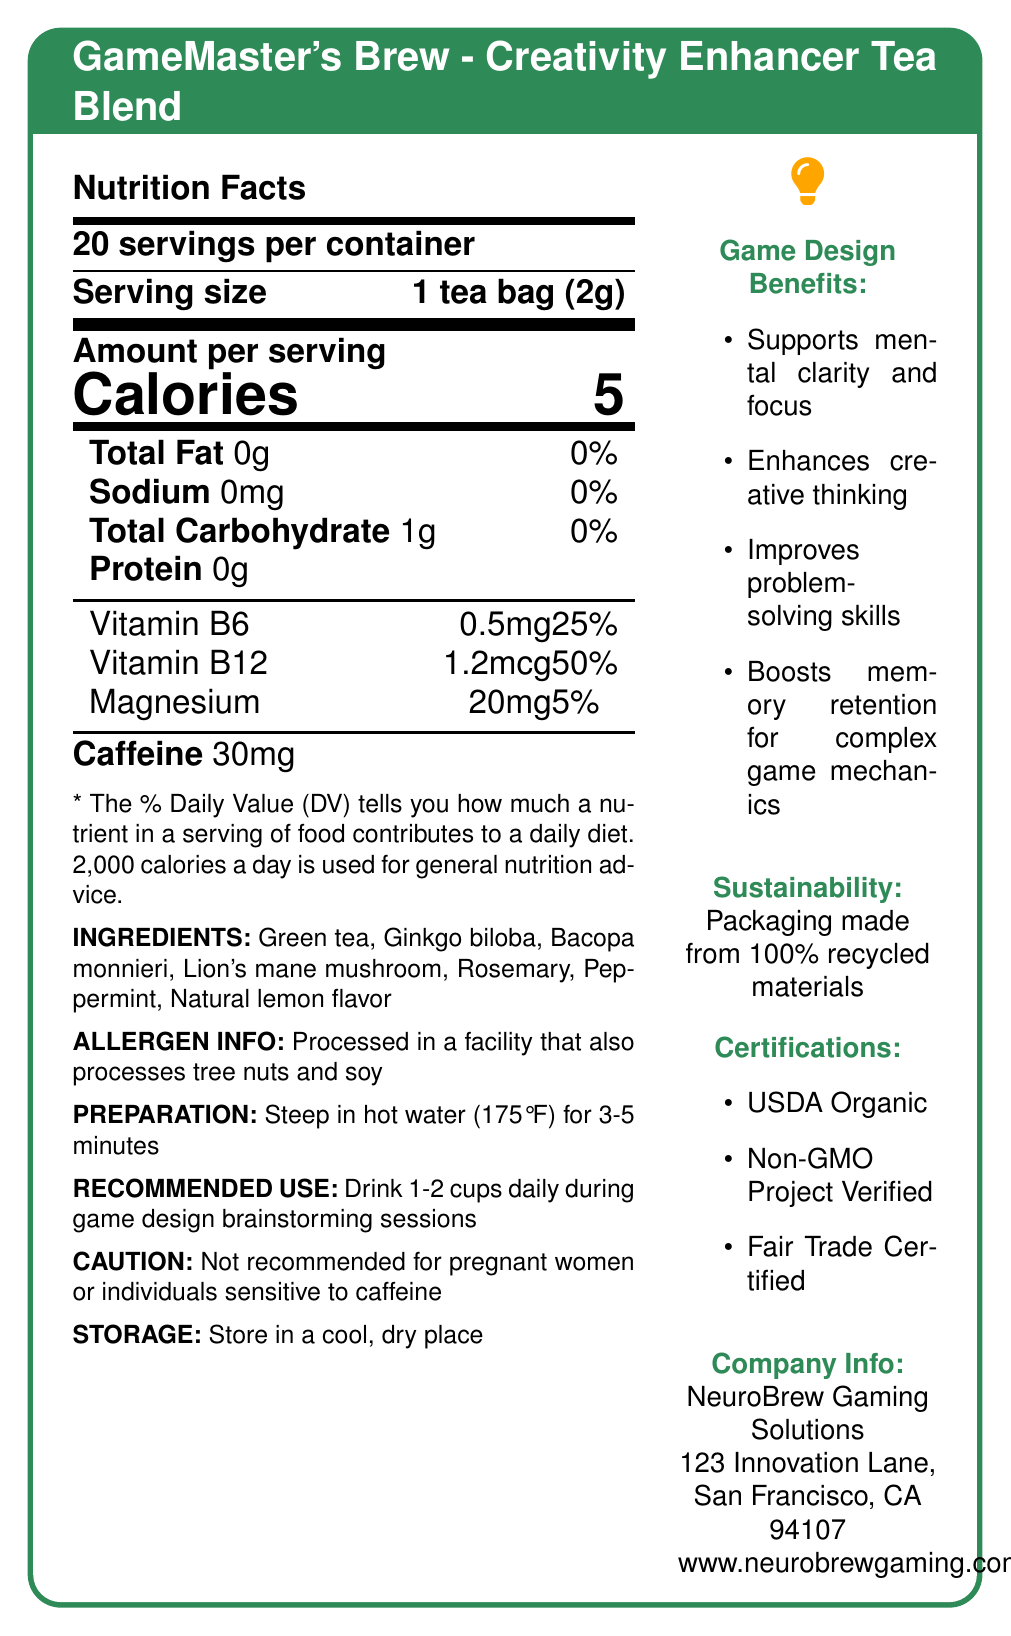What is the serving size for GameMaster's Brew? The document specifies "Serving size: 1 tea bag (2g)" in the Nutrition Facts section.
Answer: 1 tea bag (2g) How many calories are there per serving? The document states "Calories: 5" in the Nutrition Facts section.
Answer: 5 What are the ingredients in GameMaster's Brew? The ingredients are listed in the Nutrition Facts section under "INGREDIENTS."
Answer: Green tea, Ginkgo biloba, Bacopa monnieri, Lion's mane mushroom, Rosemary, Peppermint, Natural lemon flavor How much caffeine is in each serving of the tea? The Nutrition Facts section lists "Caffeine: 30mg."
Answer: 30mg What is the company address for NeuroBrew Gaming Solutions? The company address is provided in the Company Info section.
Answer: 123 Innovation Lane, San Francisco, CA 94107 Which vitamin is present in the highest daily value percentage? A. Vitamin B6 B. Vitamin B12 C. Magnesium Vitamin B6 has 25%, Vitamin B12 has 50%, and Magnesium has 5%. Therefore, Vitamin B12 has the highest daily value percentage.
Answer: B How long should the tea be steeped? A. 2-4 minutes B. 3-5 minutes C. 5-7 minutes D. 1-3 minutes The preparation instructions in the document specify "Steep in hot water (175°F) for 3-5 minutes."
Answer: B Can pregnant women safely drink GameMaster's Brew? The caution section explicitly states, "Not recommended for pregnant women or individuals sensitive to caffeine."
Answer: No What is the main idea of the GameMaster's Brew Nutrition Facts document? The document emphasizes the nutritional values, benefits for game design, and specific instructions for using GameMaster's Brew.
Answer: The document provides detailed nutritional information, ingredients, preparation instructions, and benefits of GameMaster's Brew - a creativity-enhancing tea blend designed for game developers, produced by NeuroBrew Gaming Solutions. How many servings are there per container? The document states "20 servings per container" in the Nutrition Facts section.
Answer: 20 Is this tea blend beneficial for mental clarity and focus? Under game design benefits, it lists "Supports mental clarity and focus."
Answer: Yes What certifications does GameMaster's Brew have? The certifications are listed in the document.
Answer: USDA Organic, Non-GMO Project Verified, Fair Trade Certified Which component contributes the most to the tea's effectiveness in boosting memory retention? The document lists ingredients, but it does not specify which ingredient is primarily responsible for boosting memory retention.
Answer: Cannot be determined How much protein is in each serving of GameMaster's Brew? The document lists "Protein: 0g" in the Nutrition Facts section.
Answer: 0g What is the total carbohydrate content per serving? The Nutrition Facts section states "Total Carbohydrate: 1g."
Answer: 1g What allergens are present in the processing facility for this tea? The document mentions "Processed in a facility that also processes tree nuts and soy" in the allergen info section.
Answer: Tree nuts and soy What daily value percentage of Vitamin B6 does one serving of the tea provide? The document lists "Vitamin B6: 0.5mg (25%)" in the Nutrition Facts section.
Answer: 25% 